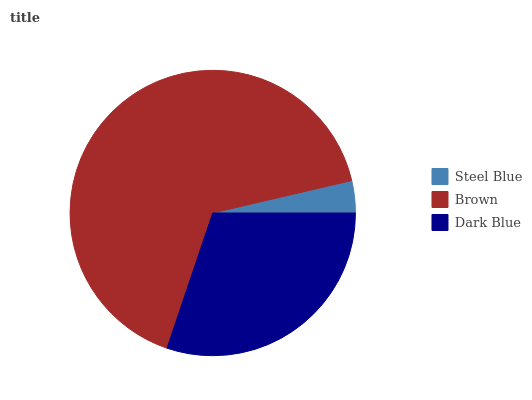Is Steel Blue the minimum?
Answer yes or no. Yes. Is Brown the maximum?
Answer yes or no. Yes. Is Dark Blue the minimum?
Answer yes or no. No. Is Dark Blue the maximum?
Answer yes or no. No. Is Brown greater than Dark Blue?
Answer yes or no. Yes. Is Dark Blue less than Brown?
Answer yes or no. Yes. Is Dark Blue greater than Brown?
Answer yes or no. No. Is Brown less than Dark Blue?
Answer yes or no. No. Is Dark Blue the high median?
Answer yes or no. Yes. Is Dark Blue the low median?
Answer yes or no. Yes. Is Steel Blue the high median?
Answer yes or no. No. Is Brown the low median?
Answer yes or no. No. 